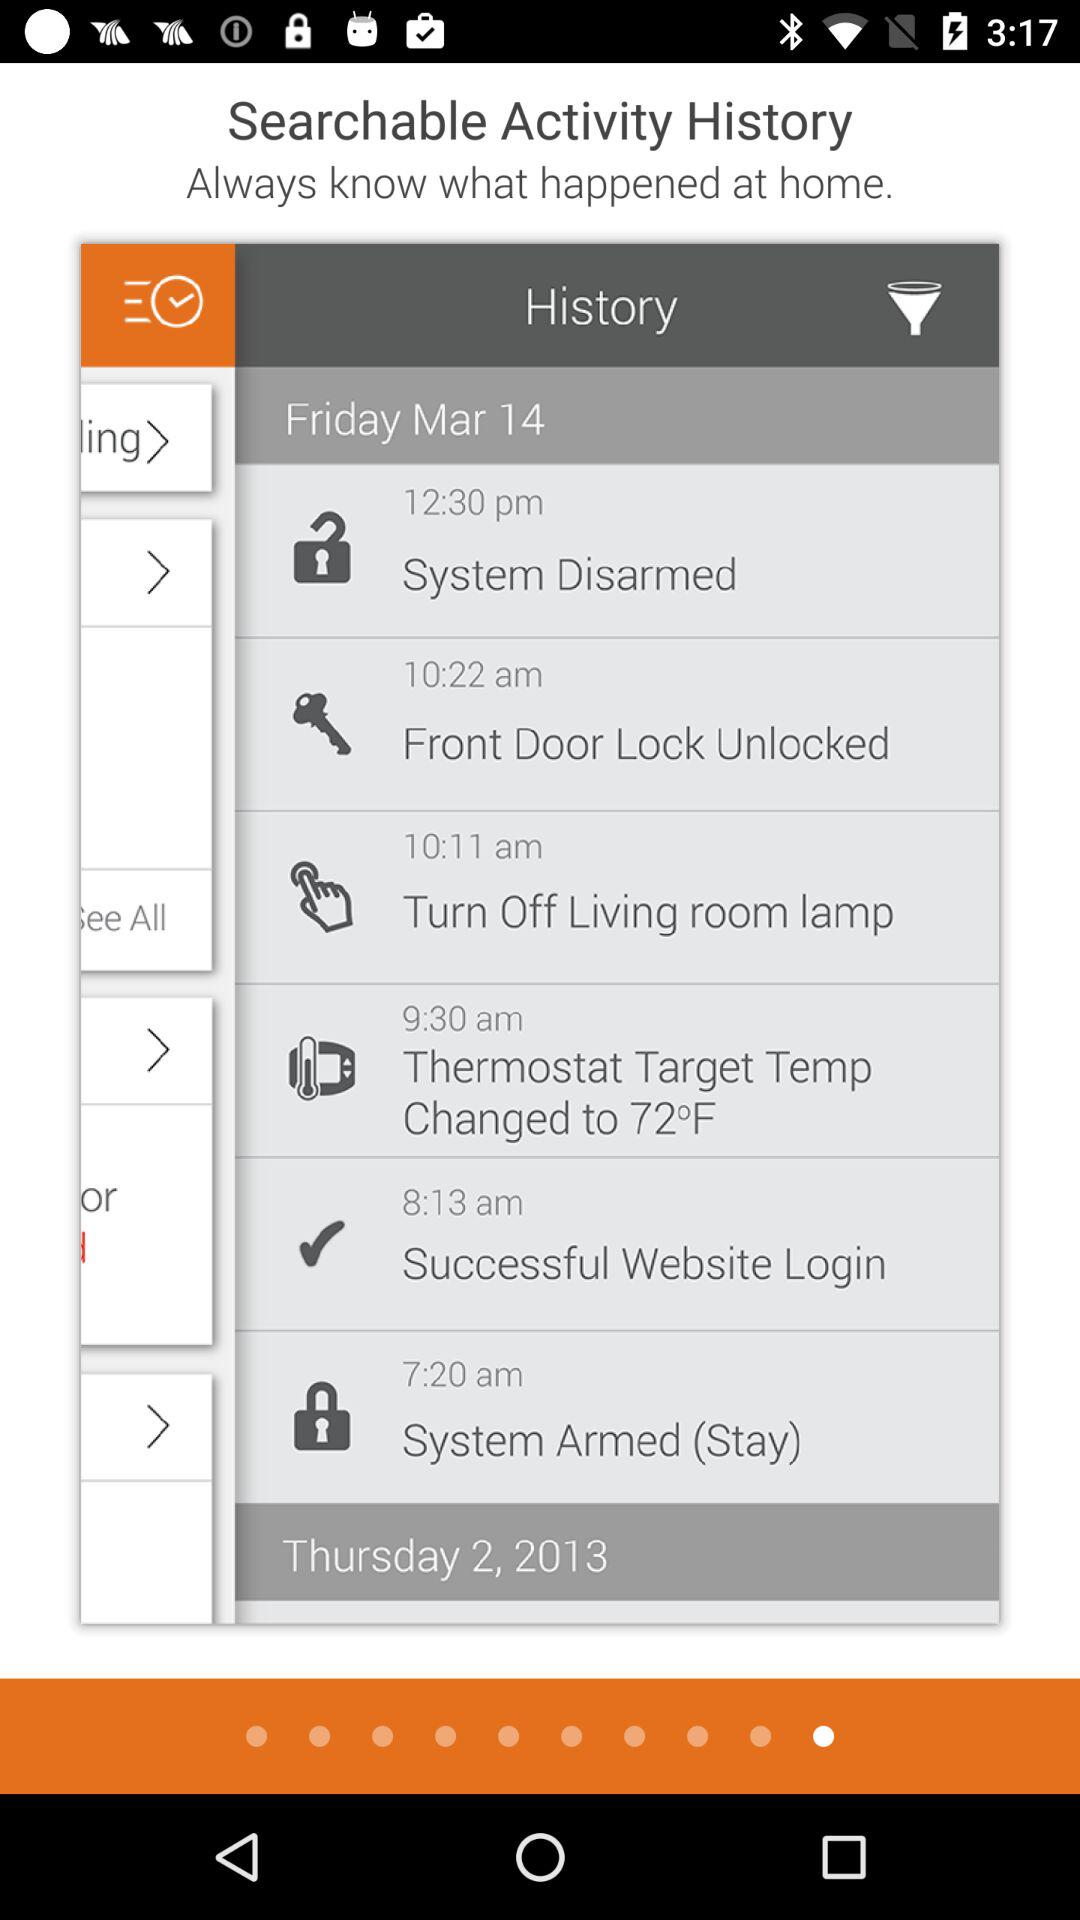What is the date mentioned in history? The date mentioned in history is Friday, March 14. 